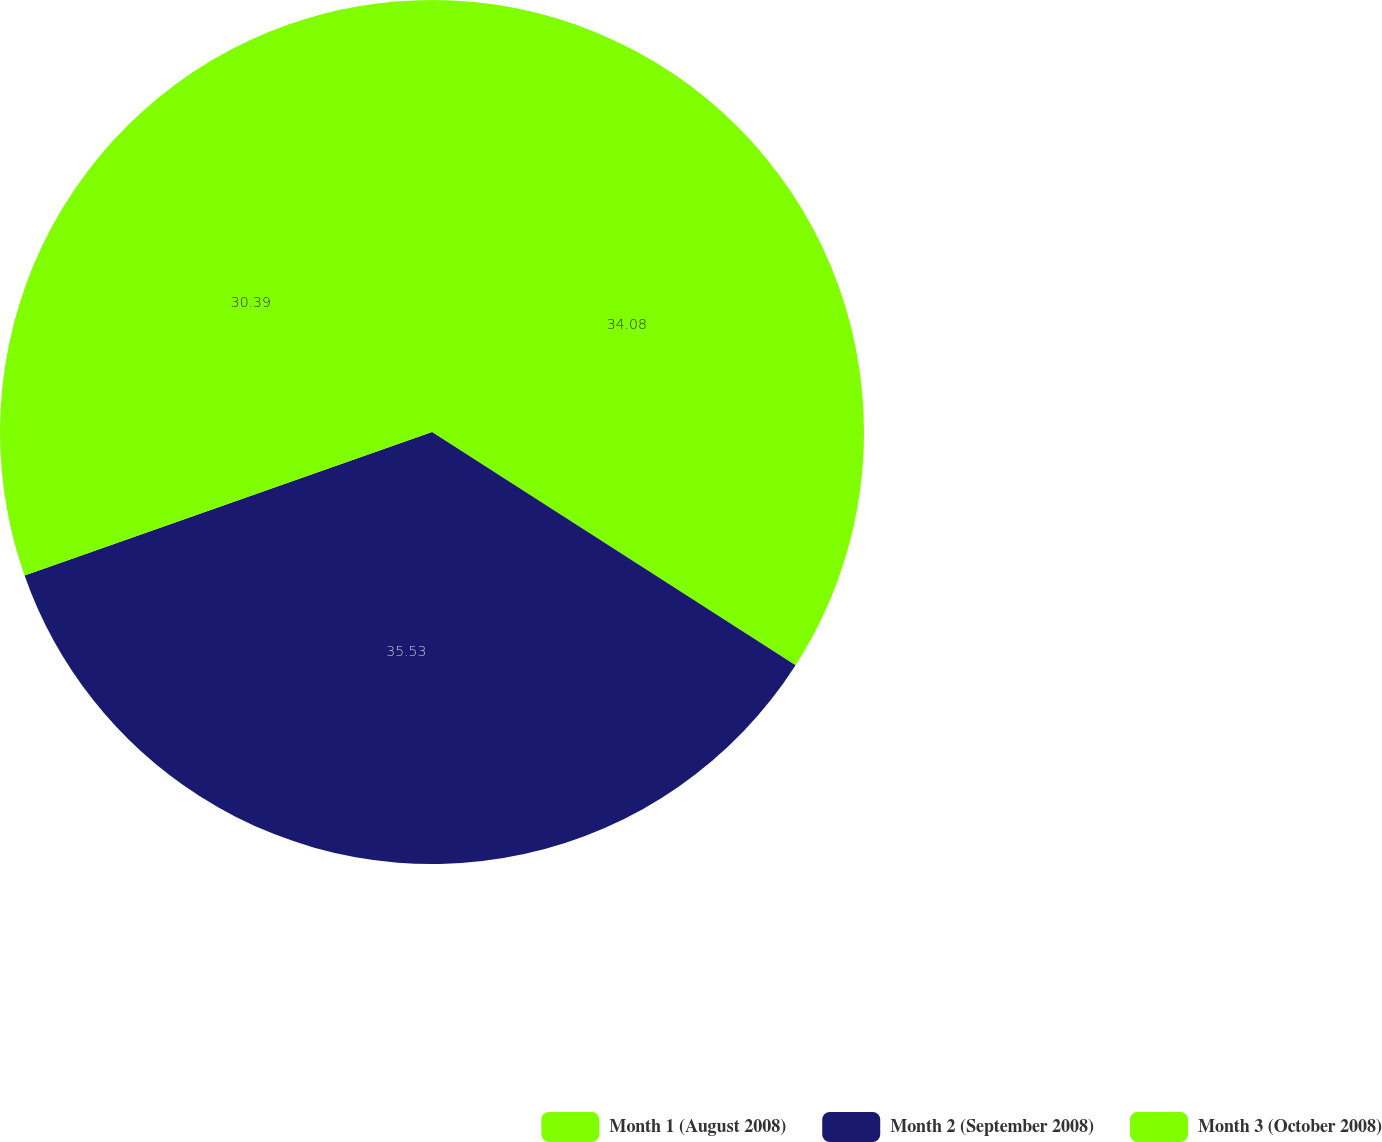<chart> <loc_0><loc_0><loc_500><loc_500><pie_chart><fcel>Month 1 (August 2008)<fcel>Month 2 (September 2008)<fcel>Month 3 (October 2008)<nl><fcel>34.08%<fcel>35.53%<fcel>30.39%<nl></chart> 